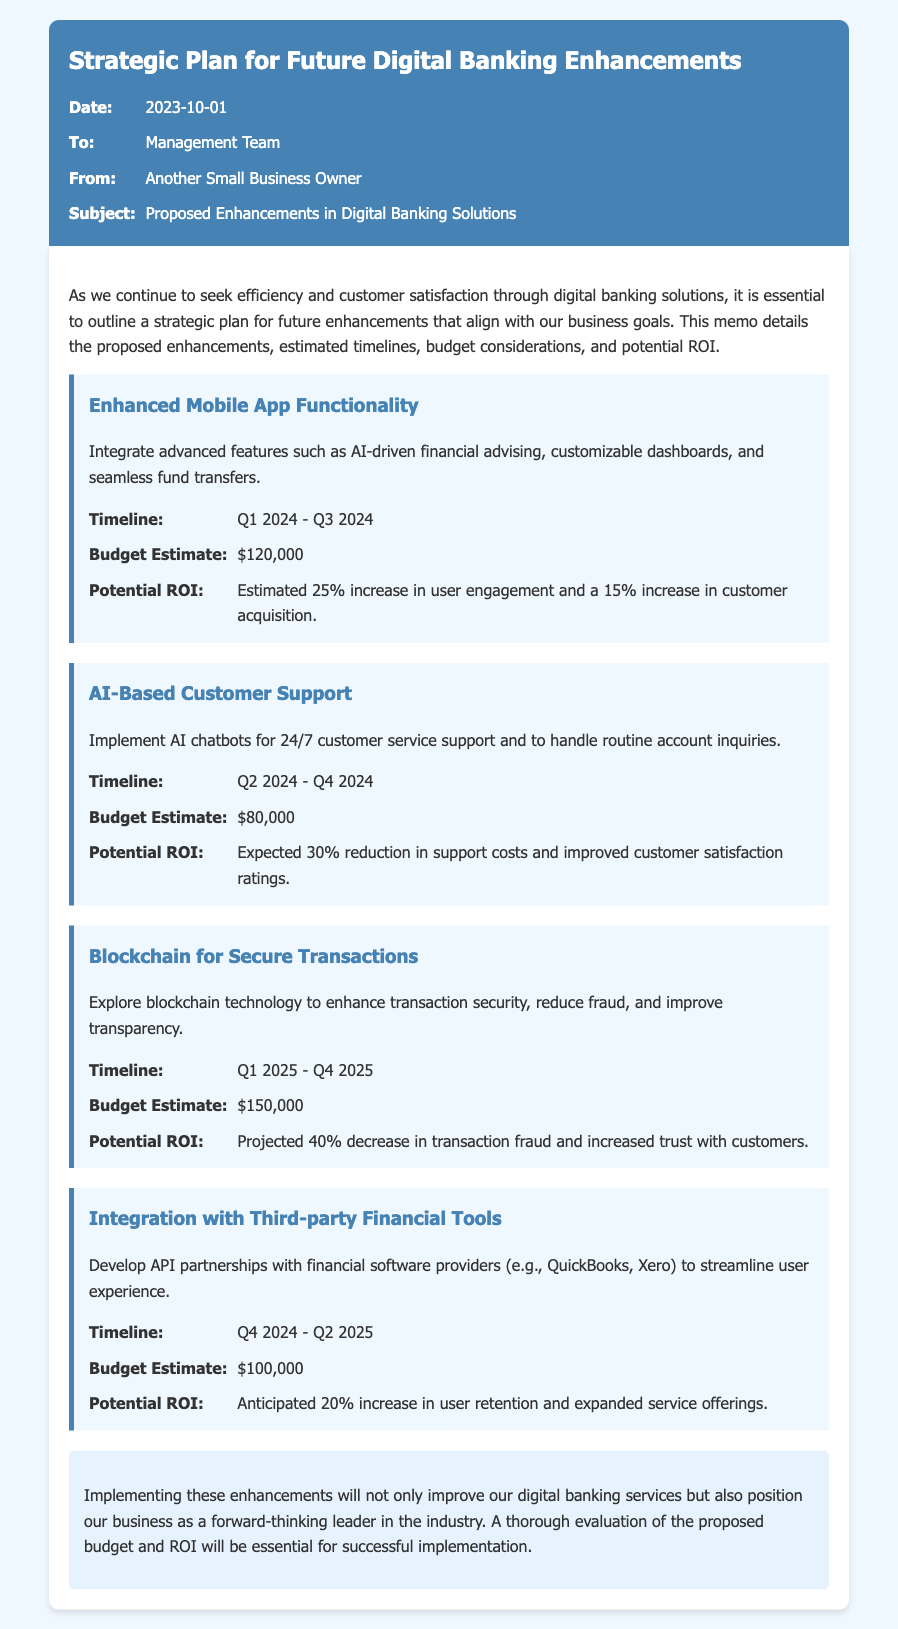What is the budget estimate for Enhanced Mobile App Functionality? The budget estimate for Enhanced Mobile App Functionality is mentioned in the document as $120,000.
Answer: $120,000 What is the potential ROI for AI-Based Customer Support? The potential ROI for AI-Based Customer Support is described in the document as a 30% reduction in support costs and improved customer satisfaction ratings.
Answer: 30% reduction in support costs What is the timeline for Blockchain for Secure Transactions? The timeline for Blockchain for Secure Transactions is specified as Q1 2025 - Q4 2025.
Answer: Q1 2025 - Q4 2025 How much is allocated for the Integration with Third-party Financial Tools? The document states that the budget estimate allocated for the Integration with Third-party Financial Tools is $100,000.
Answer: $100,000 Which enhancement is expected to decrease transaction fraud? The enhancement that is expected to decrease transaction fraud is Blockchain for Secure Transactions, as indicated in the document.
Answer: Blockchain for Secure Transactions What date was the memo written? The date the memo was written is given as 2023-10-01.
Answer: 2023-10-01 Who is the sender of the memo? The sender of the memo is Another Small Business Owner, as specified in the document.
Answer: Another Small Business Owner What is the expected increase in user retention with integration efforts? The document anticipates a 20% increase in user retention as a result of the integration with third-party financial tools.
Answer: 20% increase in user retention What is the main purpose of this strategic plan memo? The main purpose of this strategic plan memo is to outline proposed enhancements for digital banking that align with business goals.
Answer: Outline proposed enhancements for digital banking 